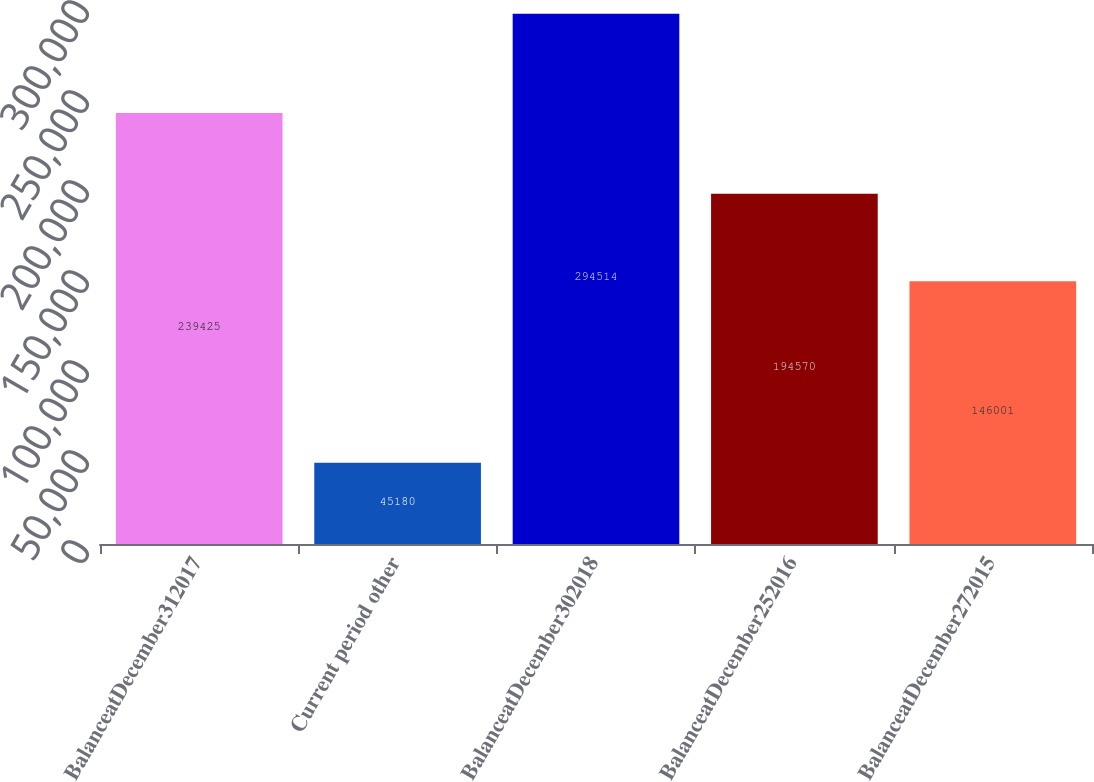<chart> <loc_0><loc_0><loc_500><loc_500><bar_chart><fcel>BalanceatDecember312017<fcel>Current period other<fcel>BalanceatDecember302018<fcel>BalanceatDecember252016<fcel>BalanceatDecember272015<nl><fcel>239425<fcel>45180<fcel>294514<fcel>194570<fcel>146001<nl></chart> 